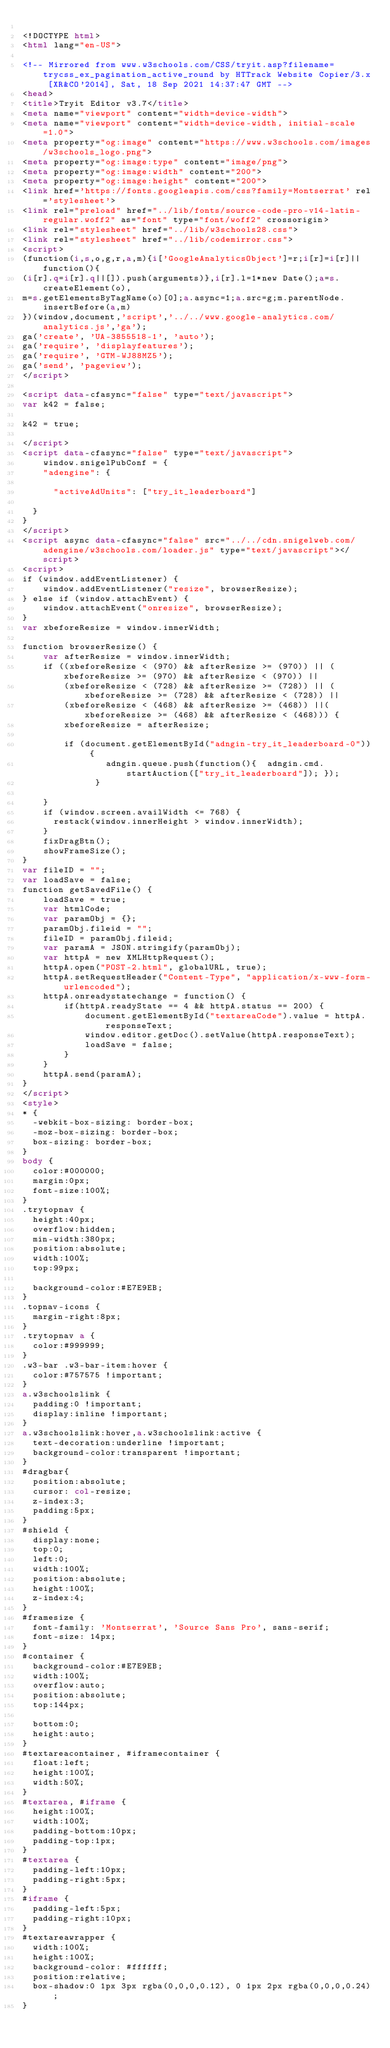Convert code to text. <code><loc_0><loc_0><loc_500><loc_500><_HTML_>
<!DOCTYPE html>
<html lang="en-US">

<!-- Mirrored from www.w3schools.com/CSS/tryit.asp?filename=trycss_ex_pagination_active_round by HTTrack Website Copier/3.x [XR&CO'2014], Sat, 18 Sep 2021 14:37:47 GMT -->
<head>
<title>Tryit Editor v3.7</title>
<meta name="viewport" content="width=device-width">
<meta name="viewport" content="width=device-width, initial-scale=1.0">
<meta property="og:image" content="https://www.w3schools.com/images/w3schools_logo.png">
<meta property="og:image:type" content="image/png">
<meta property="og:image:width" content="200">
<meta property="og:image:height" content="200">
<link href='https://fonts.googleapis.com/css?family=Montserrat' rel='stylesheet'>
<link rel="preload" href="../lib/fonts/source-code-pro-v14-latin-regular.woff2" as="font" type="font/woff2" crossorigin>
<link rel="stylesheet" href="../lib/w3schools28.css">
<link rel="stylesheet" href="../lib/codemirror.css">
<script>
(function(i,s,o,g,r,a,m){i['GoogleAnalyticsObject']=r;i[r]=i[r]||function(){
(i[r].q=i[r].q||[]).push(arguments)},i[r].l=1*new Date();a=s.createElement(o),
m=s.getElementsByTagName(o)[0];a.async=1;a.src=g;m.parentNode.insertBefore(a,m)
})(window,document,'script','../../www.google-analytics.com/analytics.js','ga');
ga('create', 'UA-3855518-1', 'auto');
ga('require', 'displayfeatures');
ga('require', 'GTM-WJ88MZ5');
ga('send', 'pageview');
</script>

<script data-cfasync="false" type="text/javascript">
var k42 = false;

k42 = true;

</script>
<script data-cfasync="false" type="text/javascript">
    window.snigelPubConf = {
    "adengine": {

      "activeAdUnits": ["try_it_leaderboard"]

  }
}
</script>
<script async data-cfasync="false" src="../../cdn.snigelweb.com/adengine/w3schools.com/loader.js" type="text/javascript"></script>
<script>
if (window.addEventListener) {              
    window.addEventListener("resize", browserResize);
} else if (window.attachEvent) {                 
    window.attachEvent("onresize", browserResize);
}
var xbeforeResize = window.innerWidth;

function browserResize() {
    var afterResize = window.innerWidth;
    if ((xbeforeResize < (970) && afterResize >= (970)) || (xbeforeResize >= (970) && afterResize < (970)) ||
        (xbeforeResize < (728) && afterResize >= (728)) || (xbeforeResize >= (728) && afterResize < (728)) ||
        (xbeforeResize < (468) && afterResize >= (468)) ||(xbeforeResize >= (468) && afterResize < (468))) {
        xbeforeResize = afterResize;
        
        if (document.getElementById("adngin-try_it_leaderboard-0")) {
                adngin.queue.push(function(){  adngin.cmd.startAuction(["try_it_leaderboard"]); });
              }
         
    }
    if (window.screen.availWidth <= 768) {
      restack(window.innerHeight > window.innerWidth);
    }
    fixDragBtn();
    showFrameSize();    
}
var fileID = "";
var loadSave = false;
function getSavedFile() {
    loadSave = true;
    var htmlCode;
    var paramObj = {};
    paramObj.fileid = "";
    fileID = paramObj.fileid;
    var paramA = JSON.stringify(paramObj);
    var httpA = new XMLHttpRequest();
    httpA.open("POST-2.html", globalURL, true);
    httpA.setRequestHeader("Content-Type", "application/x-www-form-urlencoded");
    httpA.onreadystatechange = function() {
        if(httpA.readyState == 4 && httpA.status == 200) {
            document.getElementById("textareaCode").value = httpA.responseText;
            window.editor.getDoc().setValue(httpA.responseText);
            loadSave = false;
        }
    }
    httpA.send(paramA);   
}
</script>
<style>
* {
  -webkit-box-sizing: border-box;
  -moz-box-sizing: border-box;
  box-sizing: border-box;
}
body {
  color:#000000;
  margin:0px;
  font-size:100%;
}
.trytopnav {
  height:40px;
  overflow:hidden;
  min-width:380px;
  position:absolute;
  width:100%;
  top:99px;

  background-color:#E7E9EB;
}
.topnav-icons {
  margin-right:8px;
}
.trytopnav a {
  color:#999999;
}
.w3-bar .w3-bar-item:hover {
  color:#757575 !important;
}
a.w3schoolslink {
  padding:0 !important;
  display:inline !important;
}
a.w3schoolslink:hover,a.w3schoolslink:active {
  text-decoration:underline !important;
  background-color:transparent !important;
}
#dragbar{
  position:absolute;
  cursor: col-resize;
  z-index:3;
  padding:5px;
}
#shield {
  display:none;
  top:0;
  left:0;
  width:100%;
  position:absolute;
  height:100%;
  z-index:4;
}
#framesize {
  font-family: 'Montserrat', 'Source Sans Pro', sans-serif;
  font-size: 14px;
}
#container {
  background-color:#E7E9EB;
  width:100%;
  overflow:auto;
  position:absolute;
  top:144px;

  bottom:0;
  height:auto;
}
#textareacontainer, #iframecontainer {
  float:left;
  height:100%;
  width:50%;
}
#textarea, #iframe {
  height:100%;
  width:100%;
  padding-bottom:10px;
  padding-top:1px;
}
#textarea {
  padding-left:10px;
  padding-right:5px;  
}
#iframe {
  padding-left:5px;
  padding-right:10px;  
}
#textareawrapper {
  width:100%;
  height:100%;
  background-color: #ffffff;
  position:relative;
  box-shadow:0 1px 3px rgba(0,0,0,0.12), 0 1px 2px rgba(0,0,0,0.24);
}</code> 